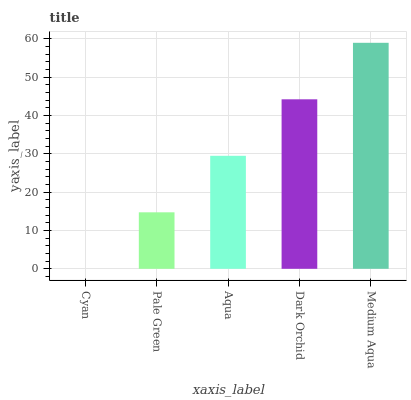Is Cyan the minimum?
Answer yes or no. Yes. Is Medium Aqua the maximum?
Answer yes or no. Yes. Is Pale Green the minimum?
Answer yes or no. No. Is Pale Green the maximum?
Answer yes or no. No. Is Pale Green greater than Cyan?
Answer yes or no. Yes. Is Cyan less than Pale Green?
Answer yes or no. Yes. Is Cyan greater than Pale Green?
Answer yes or no. No. Is Pale Green less than Cyan?
Answer yes or no. No. Is Aqua the high median?
Answer yes or no. Yes. Is Aqua the low median?
Answer yes or no. Yes. Is Cyan the high median?
Answer yes or no. No. Is Dark Orchid the low median?
Answer yes or no. No. 